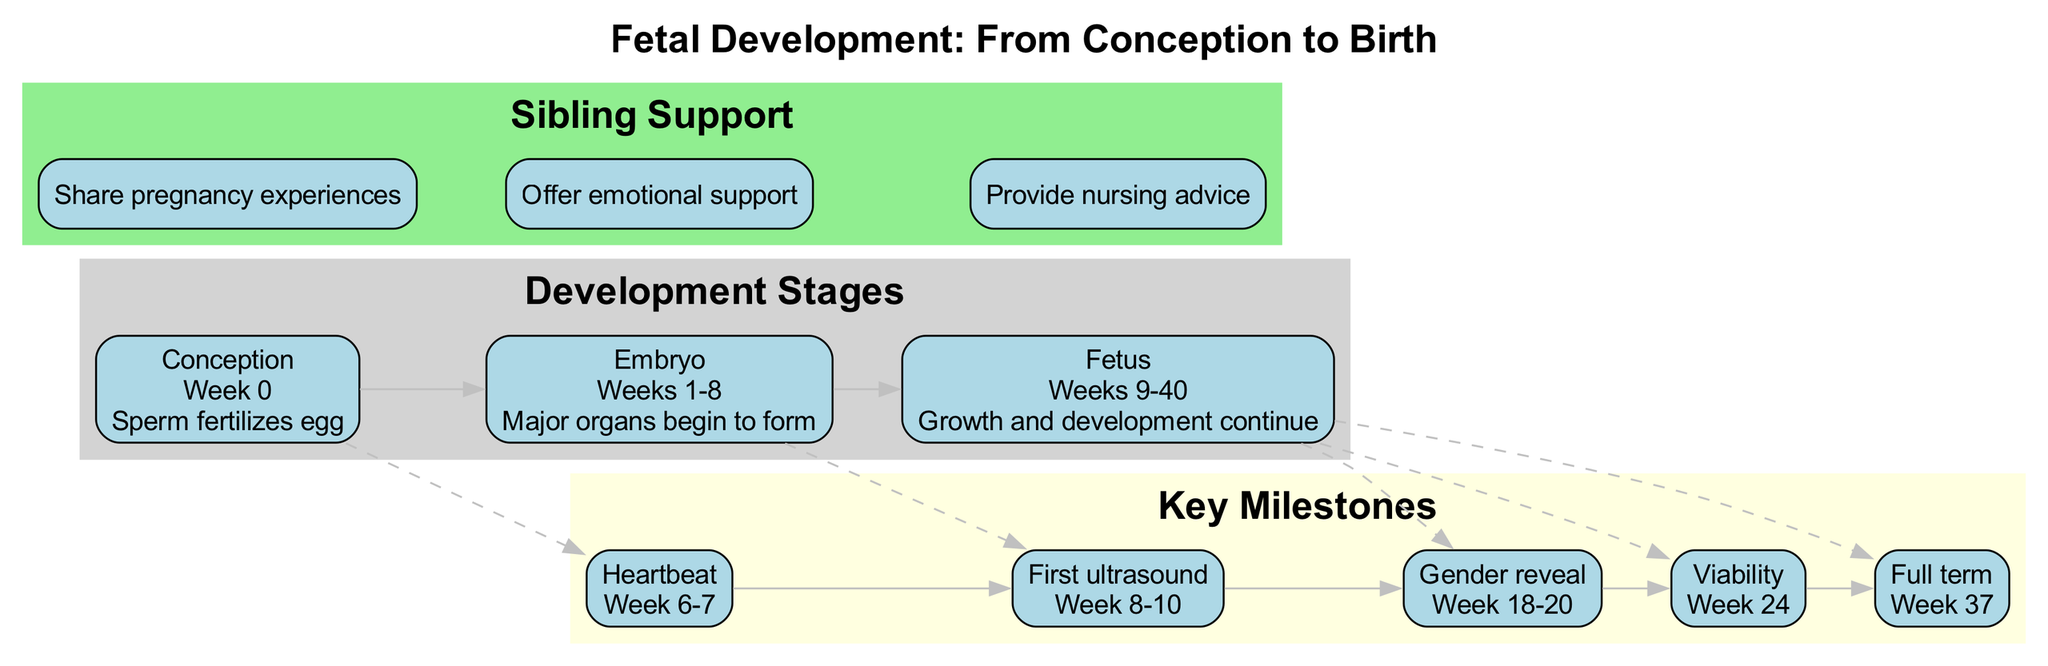What is the first stage of fetal development? The diagram shows that the first stage is labeled "Conception," which is the initial phase where sperm fertilizes the egg.
Answer: Conception In which week does the heartbeat occur? The diagram specifies that the heartbeat milestone occurs during "Week 6-7," indicating the time frame for this development.
Answer: Week 6-7 How many key milestones are there? By counting the nodes in the "Key Milestones" section of the diagram, we find that there are five different milestones listed.
Answer: 5 What stage follows the embryo? The diagram provides a direct edge linking "Embryo" to "Fetus," indicating that the stage that follows is the Fetus.
Answer: Fetus At what week does full term occur? The diagram marks the full term milestone as occurring in "Week 37," which is directly indicated in the relevant node.
Answer: Week 37 Which key milestone occurs at the same time as the gender reveal? The reasoning involves looking at the timeline, and both the "Gender reveal" and viability occur with milestones associated with the Fetus stage, but the diagram directly places the gender reveal at "Week 18-20."
Answer: Week 18-20 What is the relationship between the stages and milestones? The diagram shows dashed edges connecting the stages to milestones, indicating that each key milestone relates to a specific stage of fetal development, highlighting the progression of development.
Answer: Stages to milestones What kind of support can a sibling offer during pregnancy? The "Sibling Support" section of the diagram lists three types of support that siblings can provide, which allows us to understand their role.
Answer: Share pregnancy experiences, Offer emotional support, Provide nursing advice 